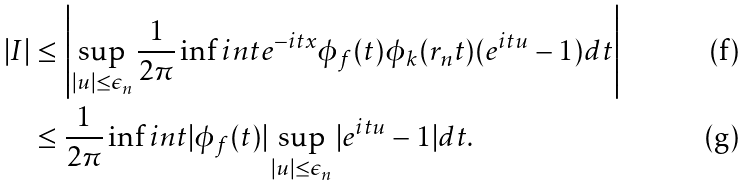Convert formula to latex. <formula><loc_0><loc_0><loc_500><loc_500>| I | & \leq \left | \sup _ { | u | \leq \epsilon _ { n } } \frac { 1 } { 2 \pi } \inf i n t e ^ { - i t x } \phi _ { f } ( t ) \phi _ { k } ( r _ { n } t ) ( e ^ { i t u } - 1 ) d t \right | \\ & \leq \frac { 1 } { 2 \pi } \inf i n t | \phi _ { f } ( t ) | \sup _ { | u | \leq \epsilon _ { n } } | e ^ { i t u } - 1 | d t .</formula> 